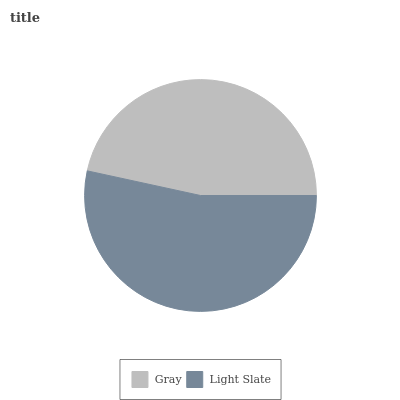Is Gray the minimum?
Answer yes or no. Yes. Is Light Slate the maximum?
Answer yes or no. Yes. Is Light Slate the minimum?
Answer yes or no. No. Is Light Slate greater than Gray?
Answer yes or no. Yes. Is Gray less than Light Slate?
Answer yes or no. Yes. Is Gray greater than Light Slate?
Answer yes or no. No. Is Light Slate less than Gray?
Answer yes or no. No. Is Light Slate the high median?
Answer yes or no. Yes. Is Gray the low median?
Answer yes or no. Yes. Is Gray the high median?
Answer yes or no. No. Is Light Slate the low median?
Answer yes or no. No. 